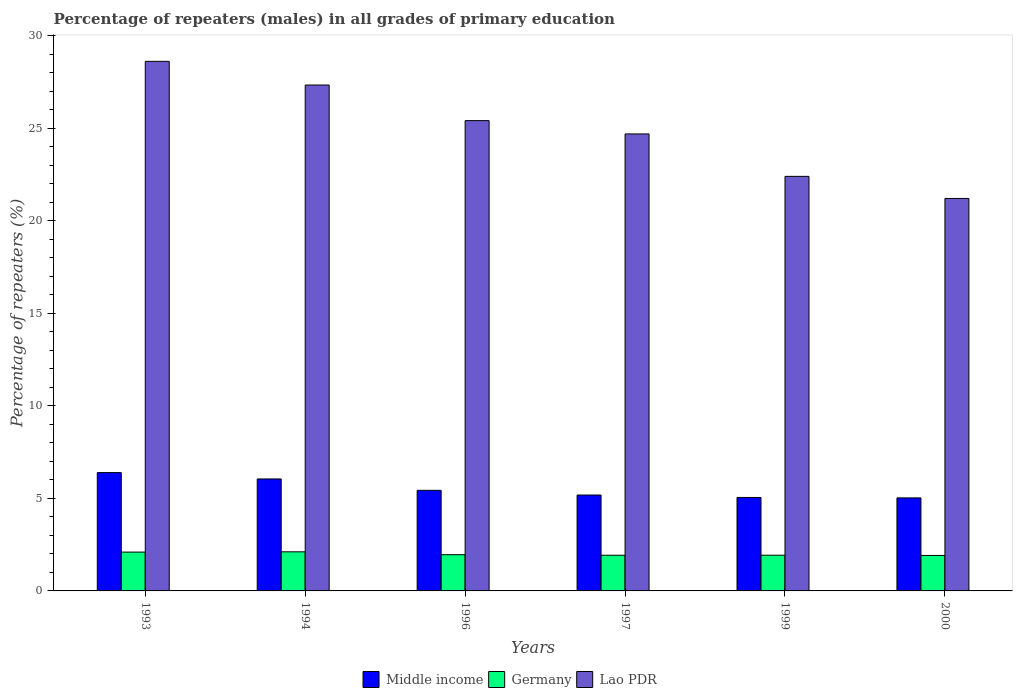Are the number of bars per tick equal to the number of legend labels?
Offer a very short reply. Yes. Are the number of bars on each tick of the X-axis equal?
Your response must be concise. Yes. How many bars are there on the 6th tick from the left?
Provide a succinct answer. 3. How many bars are there on the 4th tick from the right?
Offer a very short reply. 3. What is the label of the 5th group of bars from the left?
Your answer should be compact. 1999. In how many cases, is the number of bars for a given year not equal to the number of legend labels?
Offer a terse response. 0. What is the percentage of repeaters (males) in Lao PDR in 2000?
Offer a terse response. 21.21. Across all years, what is the maximum percentage of repeaters (males) in Germany?
Keep it short and to the point. 2.11. Across all years, what is the minimum percentage of repeaters (males) in Germany?
Ensure brevity in your answer.  1.92. What is the total percentage of repeaters (males) in Lao PDR in the graph?
Give a very brief answer. 149.7. What is the difference between the percentage of repeaters (males) in Lao PDR in 1993 and that in 1996?
Provide a succinct answer. 3.2. What is the difference between the percentage of repeaters (males) in Germany in 1997 and the percentage of repeaters (males) in Middle income in 1994?
Make the answer very short. -4.12. What is the average percentage of repeaters (males) in Germany per year?
Give a very brief answer. 1.99. In the year 1996, what is the difference between the percentage of repeaters (males) in Lao PDR and percentage of repeaters (males) in Middle income?
Offer a very short reply. 19.98. In how many years, is the percentage of repeaters (males) in Lao PDR greater than 18 %?
Provide a succinct answer. 6. What is the ratio of the percentage of repeaters (males) in Germany in 1993 to that in 1999?
Provide a succinct answer. 1.09. Is the percentage of repeaters (males) in Middle income in 1997 less than that in 1999?
Give a very brief answer. No. What is the difference between the highest and the second highest percentage of repeaters (males) in Lao PDR?
Provide a succinct answer. 1.28. What is the difference between the highest and the lowest percentage of repeaters (males) in Germany?
Give a very brief answer. 0.2. In how many years, is the percentage of repeaters (males) in Middle income greater than the average percentage of repeaters (males) in Middle income taken over all years?
Give a very brief answer. 2. What does the 2nd bar from the right in 1997 represents?
Give a very brief answer. Germany. How many bars are there?
Provide a succinct answer. 18. Are all the bars in the graph horizontal?
Give a very brief answer. No. How many years are there in the graph?
Provide a short and direct response. 6. Are the values on the major ticks of Y-axis written in scientific E-notation?
Provide a succinct answer. No. Does the graph contain any zero values?
Your answer should be compact. No. Where does the legend appear in the graph?
Ensure brevity in your answer.  Bottom center. How are the legend labels stacked?
Ensure brevity in your answer.  Horizontal. What is the title of the graph?
Your answer should be very brief. Percentage of repeaters (males) in all grades of primary education. What is the label or title of the Y-axis?
Your response must be concise. Percentage of repeaters (%). What is the Percentage of repeaters (%) of Middle income in 1993?
Ensure brevity in your answer.  6.4. What is the Percentage of repeaters (%) in Germany in 1993?
Keep it short and to the point. 2.1. What is the Percentage of repeaters (%) of Lao PDR in 1993?
Ensure brevity in your answer.  28.62. What is the Percentage of repeaters (%) in Middle income in 1994?
Offer a very short reply. 6.05. What is the Percentage of repeaters (%) of Germany in 1994?
Provide a succinct answer. 2.11. What is the Percentage of repeaters (%) in Lao PDR in 1994?
Your answer should be very brief. 27.34. What is the Percentage of repeaters (%) of Middle income in 1996?
Your answer should be compact. 5.44. What is the Percentage of repeaters (%) in Germany in 1996?
Give a very brief answer. 1.96. What is the Percentage of repeaters (%) in Lao PDR in 1996?
Your answer should be compact. 25.42. What is the Percentage of repeaters (%) in Middle income in 1997?
Offer a terse response. 5.18. What is the Percentage of repeaters (%) in Germany in 1997?
Provide a short and direct response. 1.93. What is the Percentage of repeaters (%) of Lao PDR in 1997?
Ensure brevity in your answer.  24.7. What is the Percentage of repeaters (%) of Middle income in 1999?
Ensure brevity in your answer.  5.05. What is the Percentage of repeaters (%) in Germany in 1999?
Ensure brevity in your answer.  1.93. What is the Percentage of repeaters (%) in Lao PDR in 1999?
Your answer should be very brief. 22.41. What is the Percentage of repeaters (%) of Middle income in 2000?
Your answer should be very brief. 5.03. What is the Percentage of repeaters (%) in Germany in 2000?
Offer a terse response. 1.92. What is the Percentage of repeaters (%) of Lao PDR in 2000?
Offer a very short reply. 21.21. Across all years, what is the maximum Percentage of repeaters (%) in Middle income?
Give a very brief answer. 6.4. Across all years, what is the maximum Percentage of repeaters (%) in Germany?
Your response must be concise. 2.11. Across all years, what is the maximum Percentage of repeaters (%) of Lao PDR?
Provide a succinct answer. 28.62. Across all years, what is the minimum Percentage of repeaters (%) of Middle income?
Provide a short and direct response. 5.03. Across all years, what is the minimum Percentage of repeaters (%) in Germany?
Your answer should be compact. 1.92. Across all years, what is the minimum Percentage of repeaters (%) in Lao PDR?
Your response must be concise. 21.21. What is the total Percentage of repeaters (%) of Middle income in the graph?
Make the answer very short. 33.15. What is the total Percentage of repeaters (%) of Germany in the graph?
Ensure brevity in your answer.  11.95. What is the total Percentage of repeaters (%) in Lao PDR in the graph?
Provide a short and direct response. 149.7. What is the difference between the Percentage of repeaters (%) of Middle income in 1993 and that in 1994?
Your answer should be very brief. 0.34. What is the difference between the Percentage of repeaters (%) of Germany in 1993 and that in 1994?
Your answer should be very brief. -0.01. What is the difference between the Percentage of repeaters (%) of Lao PDR in 1993 and that in 1994?
Your answer should be compact. 1.28. What is the difference between the Percentage of repeaters (%) in Middle income in 1993 and that in 1996?
Your response must be concise. 0.96. What is the difference between the Percentage of repeaters (%) of Germany in 1993 and that in 1996?
Give a very brief answer. 0.14. What is the difference between the Percentage of repeaters (%) of Lao PDR in 1993 and that in 1996?
Ensure brevity in your answer.  3.2. What is the difference between the Percentage of repeaters (%) of Middle income in 1993 and that in 1997?
Provide a succinct answer. 1.21. What is the difference between the Percentage of repeaters (%) in Germany in 1993 and that in 1997?
Give a very brief answer. 0.17. What is the difference between the Percentage of repeaters (%) of Lao PDR in 1993 and that in 1997?
Keep it short and to the point. 3.92. What is the difference between the Percentage of repeaters (%) in Middle income in 1993 and that in 1999?
Provide a succinct answer. 1.34. What is the difference between the Percentage of repeaters (%) of Germany in 1993 and that in 1999?
Offer a very short reply. 0.17. What is the difference between the Percentage of repeaters (%) of Lao PDR in 1993 and that in 1999?
Keep it short and to the point. 6.22. What is the difference between the Percentage of repeaters (%) of Middle income in 1993 and that in 2000?
Provide a short and direct response. 1.37. What is the difference between the Percentage of repeaters (%) in Germany in 1993 and that in 2000?
Your answer should be compact. 0.18. What is the difference between the Percentage of repeaters (%) of Lao PDR in 1993 and that in 2000?
Provide a short and direct response. 7.41. What is the difference between the Percentage of repeaters (%) of Middle income in 1994 and that in 1996?
Offer a terse response. 0.62. What is the difference between the Percentage of repeaters (%) of Germany in 1994 and that in 1996?
Offer a terse response. 0.16. What is the difference between the Percentage of repeaters (%) of Lao PDR in 1994 and that in 1996?
Your answer should be very brief. 1.93. What is the difference between the Percentage of repeaters (%) in Middle income in 1994 and that in 1997?
Ensure brevity in your answer.  0.87. What is the difference between the Percentage of repeaters (%) in Germany in 1994 and that in 1997?
Ensure brevity in your answer.  0.18. What is the difference between the Percentage of repeaters (%) of Lao PDR in 1994 and that in 1997?
Provide a succinct answer. 2.64. What is the difference between the Percentage of repeaters (%) of Germany in 1994 and that in 1999?
Your answer should be compact. 0.18. What is the difference between the Percentage of repeaters (%) in Lao PDR in 1994 and that in 1999?
Offer a very short reply. 4.94. What is the difference between the Percentage of repeaters (%) of Middle income in 1994 and that in 2000?
Ensure brevity in your answer.  1.02. What is the difference between the Percentage of repeaters (%) of Germany in 1994 and that in 2000?
Make the answer very short. 0.2. What is the difference between the Percentage of repeaters (%) of Lao PDR in 1994 and that in 2000?
Offer a terse response. 6.13. What is the difference between the Percentage of repeaters (%) of Middle income in 1996 and that in 1997?
Offer a very short reply. 0.25. What is the difference between the Percentage of repeaters (%) in Germany in 1996 and that in 1997?
Ensure brevity in your answer.  0.03. What is the difference between the Percentage of repeaters (%) of Lao PDR in 1996 and that in 1997?
Give a very brief answer. 0.72. What is the difference between the Percentage of repeaters (%) of Middle income in 1996 and that in 1999?
Your answer should be compact. 0.38. What is the difference between the Percentage of repeaters (%) of Germany in 1996 and that in 1999?
Provide a short and direct response. 0.03. What is the difference between the Percentage of repeaters (%) of Lao PDR in 1996 and that in 1999?
Provide a succinct answer. 3.01. What is the difference between the Percentage of repeaters (%) in Middle income in 1996 and that in 2000?
Your answer should be compact. 0.41. What is the difference between the Percentage of repeaters (%) in Germany in 1996 and that in 2000?
Provide a short and direct response. 0.04. What is the difference between the Percentage of repeaters (%) in Lao PDR in 1996 and that in 2000?
Make the answer very short. 4.21. What is the difference between the Percentage of repeaters (%) in Middle income in 1997 and that in 1999?
Your answer should be compact. 0.13. What is the difference between the Percentage of repeaters (%) in Germany in 1997 and that in 1999?
Keep it short and to the point. -0. What is the difference between the Percentage of repeaters (%) of Lao PDR in 1997 and that in 1999?
Your answer should be compact. 2.29. What is the difference between the Percentage of repeaters (%) in Middle income in 1997 and that in 2000?
Ensure brevity in your answer.  0.16. What is the difference between the Percentage of repeaters (%) in Germany in 1997 and that in 2000?
Your answer should be compact. 0.01. What is the difference between the Percentage of repeaters (%) in Lao PDR in 1997 and that in 2000?
Your answer should be very brief. 3.49. What is the difference between the Percentage of repeaters (%) in Middle income in 1999 and that in 2000?
Give a very brief answer. 0.02. What is the difference between the Percentage of repeaters (%) in Germany in 1999 and that in 2000?
Your response must be concise. 0.01. What is the difference between the Percentage of repeaters (%) of Lao PDR in 1999 and that in 2000?
Your answer should be very brief. 1.19. What is the difference between the Percentage of repeaters (%) of Middle income in 1993 and the Percentage of repeaters (%) of Germany in 1994?
Ensure brevity in your answer.  4.28. What is the difference between the Percentage of repeaters (%) in Middle income in 1993 and the Percentage of repeaters (%) in Lao PDR in 1994?
Your answer should be very brief. -20.95. What is the difference between the Percentage of repeaters (%) of Germany in 1993 and the Percentage of repeaters (%) of Lao PDR in 1994?
Ensure brevity in your answer.  -25.25. What is the difference between the Percentage of repeaters (%) of Middle income in 1993 and the Percentage of repeaters (%) of Germany in 1996?
Make the answer very short. 4.44. What is the difference between the Percentage of repeaters (%) of Middle income in 1993 and the Percentage of repeaters (%) of Lao PDR in 1996?
Make the answer very short. -19.02. What is the difference between the Percentage of repeaters (%) in Germany in 1993 and the Percentage of repeaters (%) in Lao PDR in 1996?
Ensure brevity in your answer.  -23.32. What is the difference between the Percentage of repeaters (%) of Middle income in 1993 and the Percentage of repeaters (%) of Germany in 1997?
Ensure brevity in your answer.  4.47. What is the difference between the Percentage of repeaters (%) of Middle income in 1993 and the Percentage of repeaters (%) of Lao PDR in 1997?
Offer a very short reply. -18.3. What is the difference between the Percentage of repeaters (%) in Germany in 1993 and the Percentage of repeaters (%) in Lao PDR in 1997?
Keep it short and to the point. -22.6. What is the difference between the Percentage of repeaters (%) in Middle income in 1993 and the Percentage of repeaters (%) in Germany in 1999?
Provide a succinct answer. 4.47. What is the difference between the Percentage of repeaters (%) in Middle income in 1993 and the Percentage of repeaters (%) in Lao PDR in 1999?
Provide a succinct answer. -16.01. What is the difference between the Percentage of repeaters (%) in Germany in 1993 and the Percentage of repeaters (%) in Lao PDR in 1999?
Your answer should be very brief. -20.31. What is the difference between the Percentage of repeaters (%) of Middle income in 1993 and the Percentage of repeaters (%) of Germany in 2000?
Keep it short and to the point. 4.48. What is the difference between the Percentage of repeaters (%) of Middle income in 1993 and the Percentage of repeaters (%) of Lao PDR in 2000?
Your response must be concise. -14.82. What is the difference between the Percentage of repeaters (%) in Germany in 1993 and the Percentage of repeaters (%) in Lao PDR in 2000?
Your response must be concise. -19.11. What is the difference between the Percentage of repeaters (%) in Middle income in 1994 and the Percentage of repeaters (%) in Germany in 1996?
Your answer should be very brief. 4.09. What is the difference between the Percentage of repeaters (%) of Middle income in 1994 and the Percentage of repeaters (%) of Lao PDR in 1996?
Provide a succinct answer. -19.37. What is the difference between the Percentage of repeaters (%) of Germany in 1994 and the Percentage of repeaters (%) of Lao PDR in 1996?
Your response must be concise. -23.31. What is the difference between the Percentage of repeaters (%) of Middle income in 1994 and the Percentage of repeaters (%) of Germany in 1997?
Provide a succinct answer. 4.12. What is the difference between the Percentage of repeaters (%) in Middle income in 1994 and the Percentage of repeaters (%) in Lao PDR in 1997?
Offer a terse response. -18.65. What is the difference between the Percentage of repeaters (%) in Germany in 1994 and the Percentage of repeaters (%) in Lao PDR in 1997?
Your response must be concise. -22.59. What is the difference between the Percentage of repeaters (%) in Middle income in 1994 and the Percentage of repeaters (%) in Germany in 1999?
Provide a short and direct response. 4.12. What is the difference between the Percentage of repeaters (%) of Middle income in 1994 and the Percentage of repeaters (%) of Lao PDR in 1999?
Ensure brevity in your answer.  -16.35. What is the difference between the Percentage of repeaters (%) in Germany in 1994 and the Percentage of repeaters (%) in Lao PDR in 1999?
Your answer should be compact. -20.29. What is the difference between the Percentage of repeaters (%) in Middle income in 1994 and the Percentage of repeaters (%) in Germany in 2000?
Your response must be concise. 4.13. What is the difference between the Percentage of repeaters (%) in Middle income in 1994 and the Percentage of repeaters (%) in Lao PDR in 2000?
Give a very brief answer. -15.16. What is the difference between the Percentage of repeaters (%) of Germany in 1994 and the Percentage of repeaters (%) of Lao PDR in 2000?
Your answer should be compact. -19.1. What is the difference between the Percentage of repeaters (%) of Middle income in 1996 and the Percentage of repeaters (%) of Germany in 1997?
Offer a terse response. 3.51. What is the difference between the Percentage of repeaters (%) in Middle income in 1996 and the Percentage of repeaters (%) in Lao PDR in 1997?
Your answer should be compact. -19.26. What is the difference between the Percentage of repeaters (%) of Germany in 1996 and the Percentage of repeaters (%) of Lao PDR in 1997?
Keep it short and to the point. -22.74. What is the difference between the Percentage of repeaters (%) of Middle income in 1996 and the Percentage of repeaters (%) of Germany in 1999?
Keep it short and to the point. 3.51. What is the difference between the Percentage of repeaters (%) of Middle income in 1996 and the Percentage of repeaters (%) of Lao PDR in 1999?
Provide a short and direct response. -16.97. What is the difference between the Percentage of repeaters (%) of Germany in 1996 and the Percentage of repeaters (%) of Lao PDR in 1999?
Make the answer very short. -20.45. What is the difference between the Percentage of repeaters (%) in Middle income in 1996 and the Percentage of repeaters (%) in Germany in 2000?
Provide a succinct answer. 3.52. What is the difference between the Percentage of repeaters (%) of Middle income in 1996 and the Percentage of repeaters (%) of Lao PDR in 2000?
Your answer should be very brief. -15.78. What is the difference between the Percentage of repeaters (%) in Germany in 1996 and the Percentage of repeaters (%) in Lao PDR in 2000?
Your response must be concise. -19.25. What is the difference between the Percentage of repeaters (%) of Middle income in 1997 and the Percentage of repeaters (%) of Germany in 1999?
Your answer should be very brief. 3.25. What is the difference between the Percentage of repeaters (%) of Middle income in 1997 and the Percentage of repeaters (%) of Lao PDR in 1999?
Offer a terse response. -17.22. What is the difference between the Percentage of repeaters (%) in Germany in 1997 and the Percentage of repeaters (%) in Lao PDR in 1999?
Make the answer very short. -20.48. What is the difference between the Percentage of repeaters (%) of Middle income in 1997 and the Percentage of repeaters (%) of Germany in 2000?
Keep it short and to the point. 3.27. What is the difference between the Percentage of repeaters (%) in Middle income in 1997 and the Percentage of repeaters (%) in Lao PDR in 2000?
Provide a short and direct response. -16.03. What is the difference between the Percentage of repeaters (%) in Germany in 1997 and the Percentage of repeaters (%) in Lao PDR in 2000?
Provide a short and direct response. -19.28. What is the difference between the Percentage of repeaters (%) in Middle income in 1999 and the Percentage of repeaters (%) in Germany in 2000?
Provide a succinct answer. 3.13. What is the difference between the Percentage of repeaters (%) in Middle income in 1999 and the Percentage of repeaters (%) in Lao PDR in 2000?
Ensure brevity in your answer.  -16.16. What is the difference between the Percentage of repeaters (%) in Germany in 1999 and the Percentage of repeaters (%) in Lao PDR in 2000?
Provide a succinct answer. -19.28. What is the average Percentage of repeaters (%) in Middle income per year?
Ensure brevity in your answer.  5.52. What is the average Percentage of repeaters (%) of Germany per year?
Provide a short and direct response. 1.99. What is the average Percentage of repeaters (%) of Lao PDR per year?
Ensure brevity in your answer.  24.95. In the year 1993, what is the difference between the Percentage of repeaters (%) in Middle income and Percentage of repeaters (%) in Germany?
Provide a short and direct response. 4.3. In the year 1993, what is the difference between the Percentage of repeaters (%) in Middle income and Percentage of repeaters (%) in Lao PDR?
Give a very brief answer. -22.23. In the year 1993, what is the difference between the Percentage of repeaters (%) of Germany and Percentage of repeaters (%) of Lao PDR?
Provide a succinct answer. -26.52. In the year 1994, what is the difference between the Percentage of repeaters (%) of Middle income and Percentage of repeaters (%) of Germany?
Give a very brief answer. 3.94. In the year 1994, what is the difference between the Percentage of repeaters (%) in Middle income and Percentage of repeaters (%) in Lao PDR?
Your answer should be very brief. -21.29. In the year 1994, what is the difference between the Percentage of repeaters (%) of Germany and Percentage of repeaters (%) of Lao PDR?
Offer a terse response. -25.23. In the year 1996, what is the difference between the Percentage of repeaters (%) of Middle income and Percentage of repeaters (%) of Germany?
Your response must be concise. 3.48. In the year 1996, what is the difference between the Percentage of repeaters (%) in Middle income and Percentage of repeaters (%) in Lao PDR?
Your answer should be very brief. -19.98. In the year 1996, what is the difference between the Percentage of repeaters (%) of Germany and Percentage of repeaters (%) of Lao PDR?
Provide a succinct answer. -23.46. In the year 1997, what is the difference between the Percentage of repeaters (%) in Middle income and Percentage of repeaters (%) in Germany?
Make the answer very short. 3.26. In the year 1997, what is the difference between the Percentage of repeaters (%) in Middle income and Percentage of repeaters (%) in Lao PDR?
Keep it short and to the point. -19.52. In the year 1997, what is the difference between the Percentage of repeaters (%) in Germany and Percentage of repeaters (%) in Lao PDR?
Ensure brevity in your answer.  -22.77. In the year 1999, what is the difference between the Percentage of repeaters (%) in Middle income and Percentage of repeaters (%) in Germany?
Offer a very short reply. 3.12. In the year 1999, what is the difference between the Percentage of repeaters (%) in Middle income and Percentage of repeaters (%) in Lao PDR?
Offer a terse response. -17.35. In the year 1999, what is the difference between the Percentage of repeaters (%) in Germany and Percentage of repeaters (%) in Lao PDR?
Offer a very short reply. -20.48. In the year 2000, what is the difference between the Percentage of repeaters (%) of Middle income and Percentage of repeaters (%) of Germany?
Give a very brief answer. 3.11. In the year 2000, what is the difference between the Percentage of repeaters (%) of Middle income and Percentage of repeaters (%) of Lao PDR?
Ensure brevity in your answer.  -16.18. In the year 2000, what is the difference between the Percentage of repeaters (%) in Germany and Percentage of repeaters (%) in Lao PDR?
Make the answer very short. -19.3. What is the ratio of the Percentage of repeaters (%) of Middle income in 1993 to that in 1994?
Offer a terse response. 1.06. What is the ratio of the Percentage of repeaters (%) of Lao PDR in 1993 to that in 1994?
Provide a succinct answer. 1.05. What is the ratio of the Percentage of repeaters (%) in Middle income in 1993 to that in 1996?
Give a very brief answer. 1.18. What is the ratio of the Percentage of repeaters (%) of Germany in 1993 to that in 1996?
Offer a terse response. 1.07. What is the ratio of the Percentage of repeaters (%) in Lao PDR in 1993 to that in 1996?
Offer a very short reply. 1.13. What is the ratio of the Percentage of repeaters (%) in Middle income in 1993 to that in 1997?
Ensure brevity in your answer.  1.23. What is the ratio of the Percentage of repeaters (%) of Germany in 1993 to that in 1997?
Keep it short and to the point. 1.09. What is the ratio of the Percentage of repeaters (%) in Lao PDR in 1993 to that in 1997?
Ensure brevity in your answer.  1.16. What is the ratio of the Percentage of repeaters (%) of Middle income in 1993 to that in 1999?
Offer a very short reply. 1.27. What is the ratio of the Percentage of repeaters (%) of Germany in 1993 to that in 1999?
Provide a short and direct response. 1.09. What is the ratio of the Percentage of repeaters (%) in Lao PDR in 1993 to that in 1999?
Offer a terse response. 1.28. What is the ratio of the Percentage of repeaters (%) in Middle income in 1993 to that in 2000?
Your response must be concise. 1.27. What is the ratio of the Percentage of repeaters (%) of Germany in 1993 to that in 2000?
Make the answer very short. 1.09. What is the ratio of the Percentage of repeaters (%) of Lao PDR in 1993 to that in 2000?
Your response must be concise. 1.35. What is the ratio of the Percentage of repeaters (%) in Middle income in 1994 to that in 1996?
Your response must be concise. 1.11. What is the ratio of the Percentage of repeaters (%) in Germany in 1994 to that in 1996?
Keep it short and to the point. 1.08. What is the ratio of the Percentage of repeaters (%) of Lao PDR in 1994 to that in 1996?
Offer a very short reply. 1.08. What is the ratio of the Percentage of repeaters (%) in Middle income in 1994 to that in 1997?
Ensure brevity in your answer.  1.17. What is the ratio of the Percentage of repeaters (%) of Germany in 1994 to that in 1997?
Provide a succinct answer. 1.1. What is the ratio of the Percentage of repeaters (%) of Lao PDR in 1994 to that in 1997?
Keep it short and to the point. 1.11. What is the ratio of the Percentage of repeaters (%) in Middle income in 1994 to that in 1999?
Make the answer very short. 1.2. What is the ratio of the Percentage of repeaters (%) of Germany in 1994 to that in 1999?
Make the answer very short. 1.09. What is the ratio of the Percentage of repeaters (%) of Lao PDR in 1994 to that in 1999?
Your answer should be very brief. 1.22. What is the ratio of the Percentage of repeaters (%) of Middle income in 1994 to that in 2000?
Keep it short and to the point. 1.2. What is the ratio of the Percentage of repeaters (%) in Germany in 1994 to that in 2000?
Keep it short and to the point. 1.1. What is the ratio of the Percentage of repeaters (%) of Lao PDR in 1994 to that in 2000?
Give a very brief answer. 1.29. What is the ratio of the Percentage of repeaters (%) in Middle income in 1996 to that in 1997?
Your response must be concise. 1.05. What is the ratio of the Percentage of repeaters (%) of Germany in 1996 to that in 1997?
Offer a very short reply. 1.02. What is the ratio of the Percentage of repeaters (%) of Lao PDR in 1996 to that in 1997?
Make the answer very short. 1.03. What is the ratio of the Percentage of repeaters (%) of Middle income in 1996 to that in 1999?
Your response must be concise. 1.08. What is the ratio of the Percentage of repeaters (%) of Germany in 1996 to that in 1999?
Offer a very short reply. 1.01. What is the ratio of the Percentage of repeaters (%) in Lao PDR in 1996 to that in 1999?
Provide a succinct answer. 1.13. What is the ratio of the Percentage of repeaters (%) in Middle income in 1996 to that in 2000?
Provide a short and direct response. 1.08. What is the ratio of the Percentage of repeaters (%) of Germany in 1996 to that in 2000?
Ensure brevity in your answer.  1.02. What is the ratio of the Percentage of repeaters (%) of Lao PDR in 1996 to that in 2000?
Keep it short and to the point. 1.2. What is the ratio of the Percentage of repeaters (%) of Middle income in 1997 to that in 1999?
Your response must be concise. 1.03. What is the ratio of the Percentage of repeaters (%) of Germany in 1997 to that in 1999?
Make the answer very short. 1. What is the ratio of the Percentage of repeaters (%) in Lao PDR in 1997 to that in 1999?
Offer a terse response. 1.1. What is the ratio of the Percentage of repeaters (%) in Middle income in 1997 to that in 2000?
Provide a short and direct response. 1.03. What is the ratio of the Percentage of repeaters (%) in Lao PDR in 1997 to that in 2000?
Offer a terse response. 1.16. What is the ratio of the Percentage of repeaters (%) in Lao PDR in 1999 to that in 2000?
Ensure brevity in your answer.  1.06. What is the difference between the highest and the second highest Percentage of repeaters (%) in Middle income?
Your answer should be compact. 0.34. What is the difference between the highest and the second highest Percentage of repeaters (%) in Germany?
Offer a very short reply. 0.01. What is the difference between the highest and the second highest Percentage of repeaters (%) of Lao PDR?
Your response must be concise. 1.28. What is the difference between the highest and the lowest Percentage of repeaters (%) of Middle income?
Your answer should be compact. 1.37. What is the difference between the highest and the lowest Percentage of repeaters (%) of Germany?
Offer a very short reply. 0.2. What is the difference between the highest and the lowest Percentage of repeaters (%) of Lao PDR?
Make the answer very short. 7.41. 